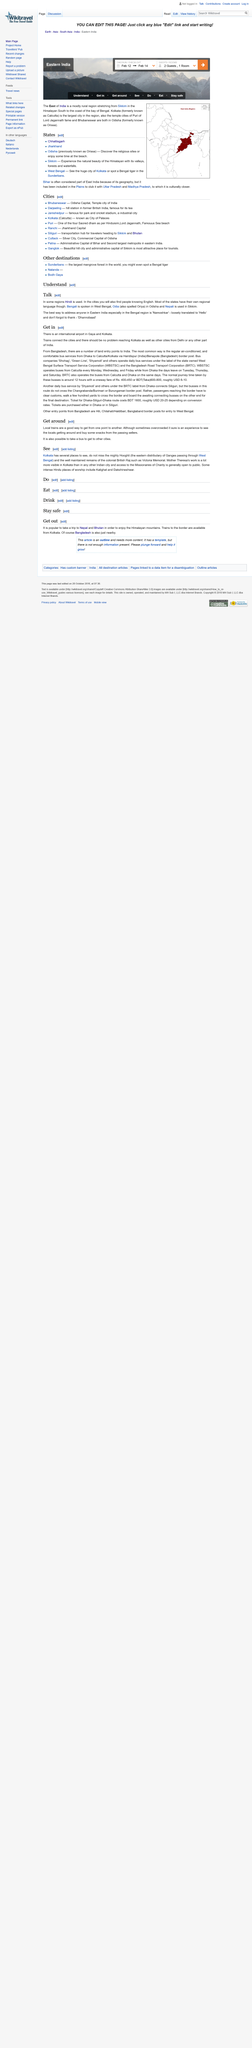Specify some key components in this picture. Some Hindu places of worship can be found at Kalighat and Dakshineshwar. It is recommended that individuals opt for local trains as a means of transportation when traveling around the area, as while they may occasionally be overcrowded, they provide an efficient and convenient way to travel between different points. The Hooghli is a distributary of the river Ganges that arises in West Bengal and flows eastward, serving as a crucial waterway for the region. Bengali is the regional language spoken in the Indian state of West Bengal. Odisha, a state in India, is known for its regional language, which is Odia (also known as Oriya). 